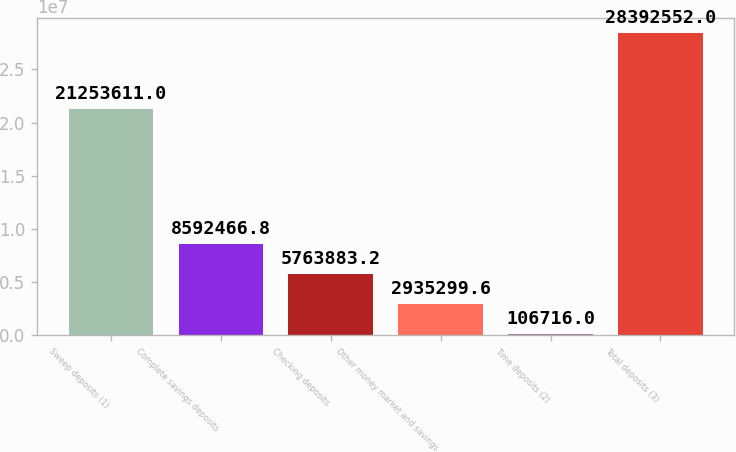<chart> <loc_0><loc_0><loc_500><loc_500><bar_chart><fcel>Sweep deposits (1)<fcel>Complete savings deposits<fcel>Checking deposits<fcel>Other money market and savings<fcel>Time deposits (2)<fcel>Total deposits (3)<nl><fcel>2.12536e+07<fcel>8.59247e+06<fcel>5.76388e+06<fcel>2.9353e+06<fcel>106716<fcel>2.83926e+07<nl></chart> 